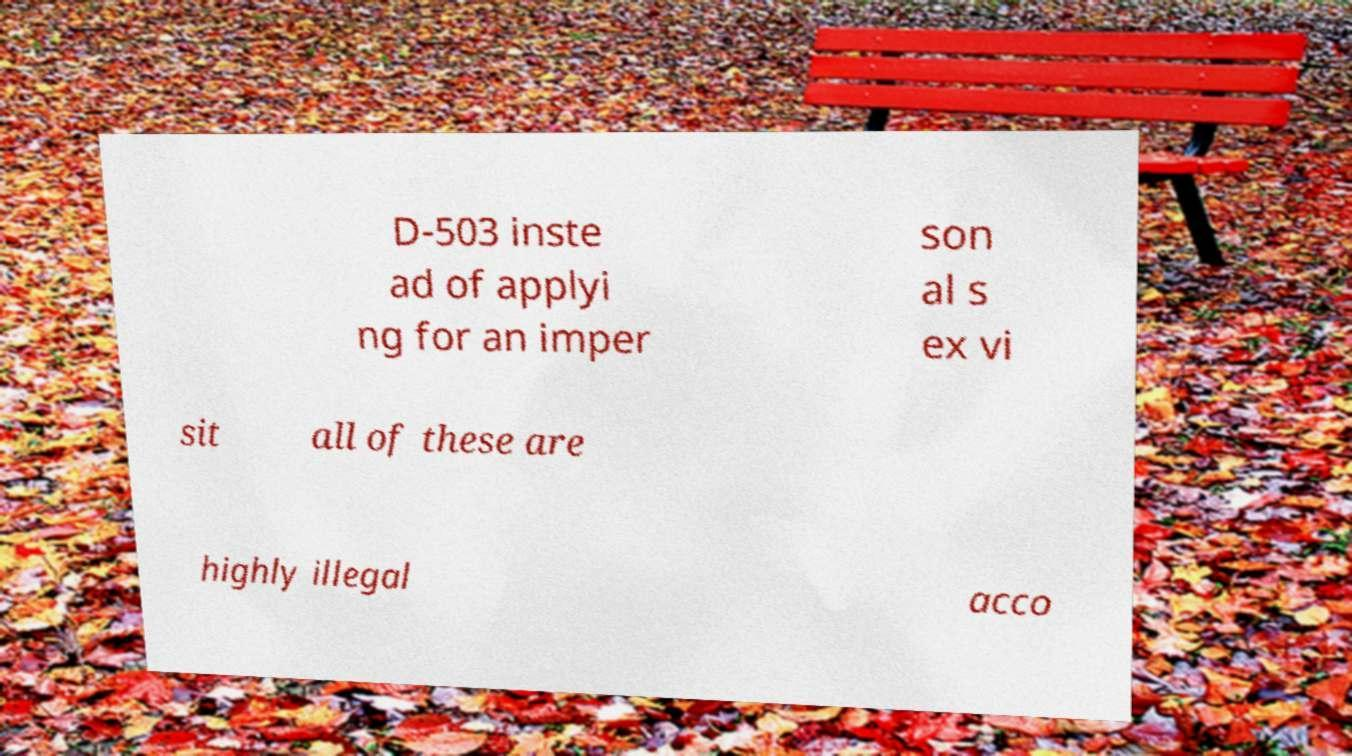Could you assist in decoding the text presented in this image and type it out clearly? D-503 inste ad of applyi ng for an imper son al s ex vi sit all of these are highly illegal acco 